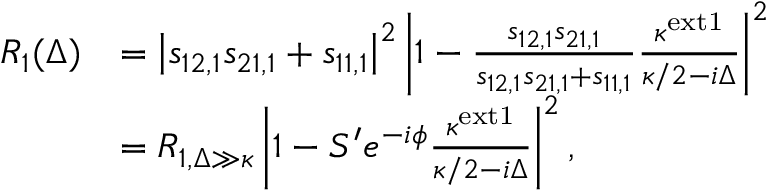<formula> <loc_0><loc_0><loc_500><loc_500>\begin{array} { r l } { R _ { 1 } ( \Delta ) } & { = \left | s _ { 1 2 , 1 } s _ { 2 1 , 1 } + s _ { 1 1 , 1 } \right | ^ { 2 } \left | 1 - \frac { s _ { 1 2 , 1 } s _ { 2 1 , 1 } } { s _ { 1 2 , 1 } s _ { 2 1 , 1 } + s _ { 1 1 , 1 } } \frac { \kappa ^ { e x t 1 } } { \kappa / 2 - i \Delta } \right | ^ { 2 } } \\ & { = R _ { 1 , \Delta \gg \kappa } \left | 1 - S ^ { \prime } e ^ { - i \phi } \frac { \kappa ^ { e x t 1 } } { \kappa / 2 - i \Delta } \right | ^ { 2 } , } \end{array}</formula> 